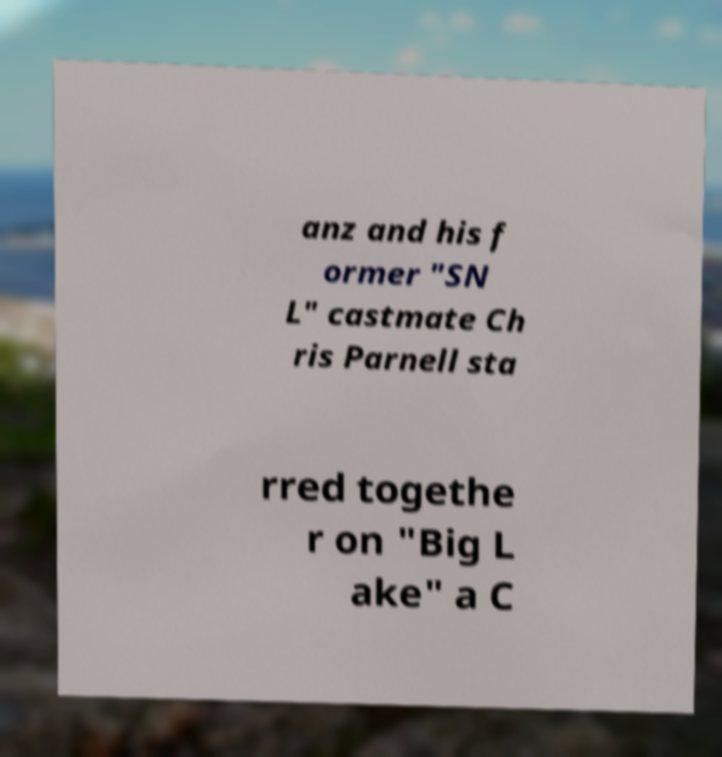Could you assist in decoding the text presented in this image and type it out clearly? anz and his f ormer "SN L" castmate Ch ris Parnell sta rred togethe r on "Big L ake" a C 